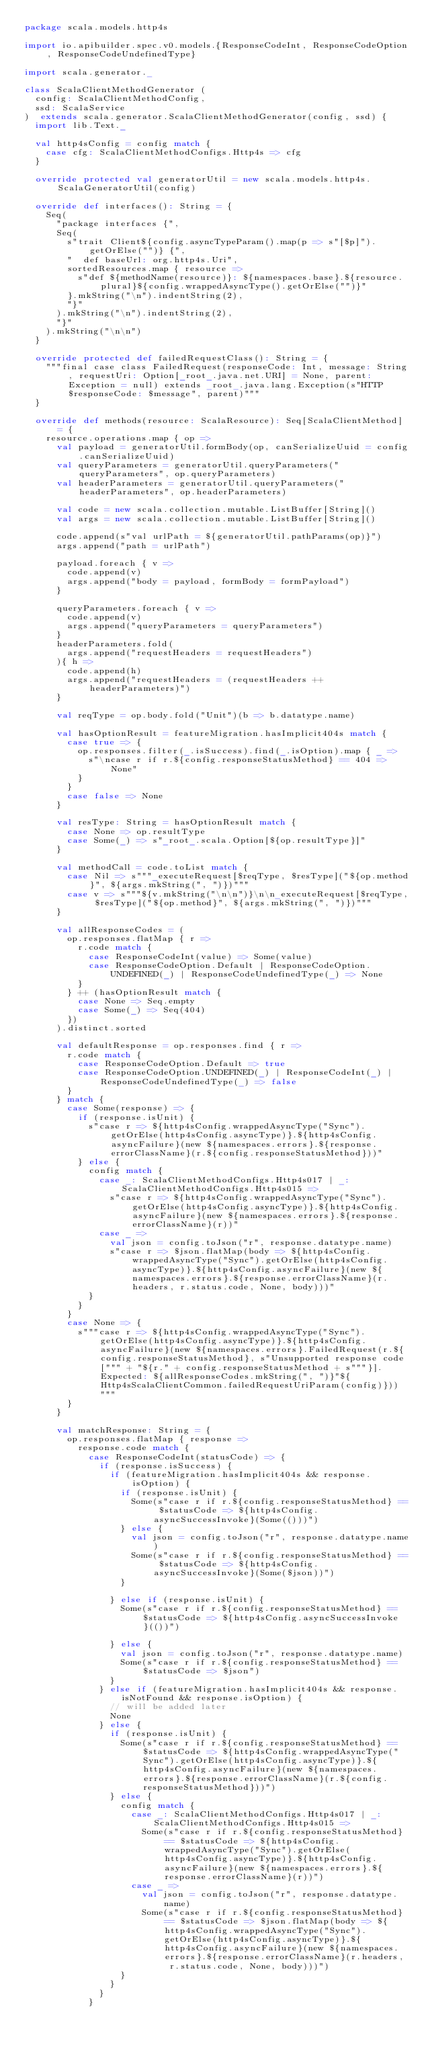<code> <loc_0><loc_0><loc_500><loc_500><_Scala_>package scala.models.http4s

import io.apibuilder.spec.v0.models.{ResponseCodeInt, ResponseCodeOption, ResponseCodeUndefinedType}

import scala.generator._

class ScalaClientMethodGenerator (
  config: ScalaClientMethodConfig,
  ssd: ScalaService
)  extends scala.generator.ScalaClientMethodGenerator(config, ssd) {
  import lib.Text._

  val http4sConfig = config match {
    case cfg: ScalaClientMethodConfigs.Http4s => cfg
  }

  override protected val generatorUtil = new scala.models.http4s.ScalaGeneratorUtil(config)

  override def interfaces(): String = {
    Seq(
      "package interfaces {",
      Seq(
        s"trait Client${config.asyncTypeParam().map(p => s"[$p]").getOrElse("")} {",
        "  def baseUrl: org.http4s.Uri",
        sortedResources.map { resource =>
          s"def ${methodName(resource)}: ${namespaces.base}.${resource.plural}${config.wrappedAsyncType().getOrElse("")}"
        }.mkString("\n").indentString(2),
        "}"
      ).mkString("\n").indentString(2),
      "}"
    ).mkString("\n\n")
  }

  override protected def failedRequestClass(): String = {
    """final case class FailedRequest(responseCode: Int, message: String, requestUri: Option[_root_.java.net.URI] = None, parent: Exception = null) extends _root_.java.lang.Exception(s"HTTP $responseCode: $message", parent)"""
  }

  override def methods(resource: ScalaResource): Seq[ScalaClientMethod] = {
    resource.operations.map { op =>
      val payload = generatorUtil.formBody(op, canSerializeUuid = config.canSerializeUuid)
      val queryParameters = generatorUtil.queryParameters("queryParameters", op.queryParameters)
      val headerParameters = generatorUtil.queryParameters("headerParameters", op.headerParameters)

      val code = new scala.collection.mutable.ListBuffer[String]()
      val args = new scala.collection.mutable.ListBuffer[String]()

      code.append(s"val urlPath = ${generatorUtil.pathParams(op)}")
      args.append("path = urlPath")

      payload.foreach { v =>
        code.append(v)
        args.append("body = payload, formBody = formPayload")
      }

      queryParameters.foreach { v =>
        code.append(v)
        args.append("queryParameters = queryParameters")
      }
      headerParameters.fold(
        args.append("requestHeaders = requestHeaders")
      ){ h =>
        code.append(h)
        args.append("requestHeaders = (requestHeaders ++ headerParameters)")
      }

      val reqType = op.body.fold("Unit")(b => b.datatype.name)

      val hasOptionResult = featureMigration.hasImplicit404s match {
        case true => {
          op.responses.filter(_.isSuccess).find(_.isOption).map { _ =>
            s"\ncase r if r.${config.responseStatusMethod} == 404 => None"
          }
        }
        case false => None
      }

      val resType: String = hasOptionResult match {
        case None => op.resultType
        case Some(_) => s"_root_.scala.Option[${op.resultType}]"
      }

      val methodCall = code.toList match {
        case Nil => s"""_executeRequest[$reqType, $resType]("${op.method}", ${args.mkString(", ")})"""
        case v => s"""${v.mkString("\n\n")}\n\n_executeRequest[$reqType, $resType]("${op.method}", ${args.mkString(", ")})"""
      }

      val allResponseCodes = (
        op.responses.flatMap { r =>
          r.code match {
            case ResponseCodeInt(value) => Some(value)
            case ResponseCodeOption.Default | ResponseCodeOption.UNDEFINED(_) | ResponseCodeUndefinedType(_) => None
          }
        } ++ (hasOptionResult match {
          case None => Seq.empty
          case Some(_) => Seq(404)
        })
      ).distinct.sorted

      val defaultResponse = op.responses.find { r =>
        r.code match {
          case ResponseCodeOption.Default => true
          case ResponseCodeOption.UNDEFINED(_) | ResponseCodeInt(_) | ResponseCodeUndefinedType(_) => false
        }
      } match {
        case Some(response) => {
          if (response.isUnit) {
            s"case r => ${http4sConfig.wrappedAsyncType("Sync").getOrElse(http4sConfig.asyncType)}.${http4sConfig.asyncFailure}(new ${namespaces.errors}.${response.errorClassName}(r.${config.responseStatusMethod}))"
          } else {
            config match {
              case _: ScalaClientMethodConfigs.Http4s017 | _: ScalaClientMethodConfigs.Http4s015 =>
                s"case r => ${http4sConfig.wrappedAsyncType("Sync").getOrElse(http4sConfig.asyncType)}.${http4sConfig.asyncFailure}(new ${namespaces.errors}.${response.errorClassName}(r))"
              case _ =>
                val json = config.toJson("r", response.datatype.name)
                s"case r => $json.flatMap(body => ${http4sConfig.wrappedAsyncType("Sync").getOrElse(http4sConfig.asyncType)}.${http4sConfig.asyncFailure}(new ${namespaces.errors}.${response.errorClassName}(r.headers, r.status.code, None, body)))"
            }
          }
        }
        case None => {
          s"""case r => ${http4sConfig.wrappedAsyncType("Sync").getOrElse(http4sConfig.asyncType)}.${http4sConfig.asyncFailure}(new ${namespaces.errors}.FailedRequest(r.${config.responseStatusMethod}, s"Unsupported response code[""" + "${r." + config.responseStatusMethod + s"""}]. Expected: ${allResponseCodes.mkString(", ")}"${Http4sScalaClientCommon.failedRequestUriParam(config)}))"""
        }
      }

      val matchResponse: String = {
        op.responses.flatMap { response =>
          response.code match {
            case ResponseCodeInt(statusCode) => {
              if (response.isSuccess) {
                if (featureMigration.hasImplicit404s && response.isOption) {
                  if (response.isUnit) {
                    Some(s"case r if r.${config.responseStatusMethod} == $statusCode => ${http4sConfig.asyncSuccessInvoke}(Some(()))")
                  } else {
                    val json = config.toJson("r", response.datatype.name)
                    Some(s"case r if r.${config.responseStatusMethod} == $statusCode => ${http4sConfig.asyncSuccessInvoke}(Some($json))")
                  }

                } else if (response.isUnit) {
                  Some(s"case r if r.${config.responseStatusMethod} == $statusCode => ${http4sConfig.asyncSuccessInvoke}(())")

                } else {
                  val json = config.toJson("r", response.datatype.name)
                  Some(s"case r if r.${config.responseStatusMethod} == $statusCode => $json")
                }
              } else if (featureMigration.hasImplicit404s && response.isNotFound && response.isOption) {
                // will be added later
                None
              } else {
                if (response.isUnit) {
                  Some(s"case r if r.${config.responseStatusMethod} == $statusCode => ${http4sConfig.wrappedAsyncType("Sync").getOrElse(http4sConfig.asyncType)}.${http4sConfig.asyncFailure}(new ${namespaces.errors}.${response.errorClassName}(r.${config.responseStatusMethod}))")
                } else {
                  config match {
                    case _: ScalaClientMethodConfigs.Http4s017 | _: ScalaClientMethodConfigs.Http4s015 =>
                      Some(s"case r if r.${config.responseStatusMethod} == $statusCode => ${http4sConfig.wrappedAsyncType("Sync").getOrElse(http4sConfig.asyncType)}.${http4sConfig.asyncFailure}(new ${namespaces.errors}.${response.errorClassName}(r))")
                    case _ =>
                      val json = config.toJson("r", response.datatype.name)
                      Some(s"case r if r.${config.responseStatusMethod} == $statusCode => $json.flatMap(body => ${http4sConfig.wrappedAsyncType("Sync").getOrElse(http4sConfig.asyncType)}.${http4sConfig.asyncFailure}(new ${namespaces.errors}.${response.errorClassName}(r.headers, r.status.code, None, body)))")
                  }
                }
              }
            }
</code> 